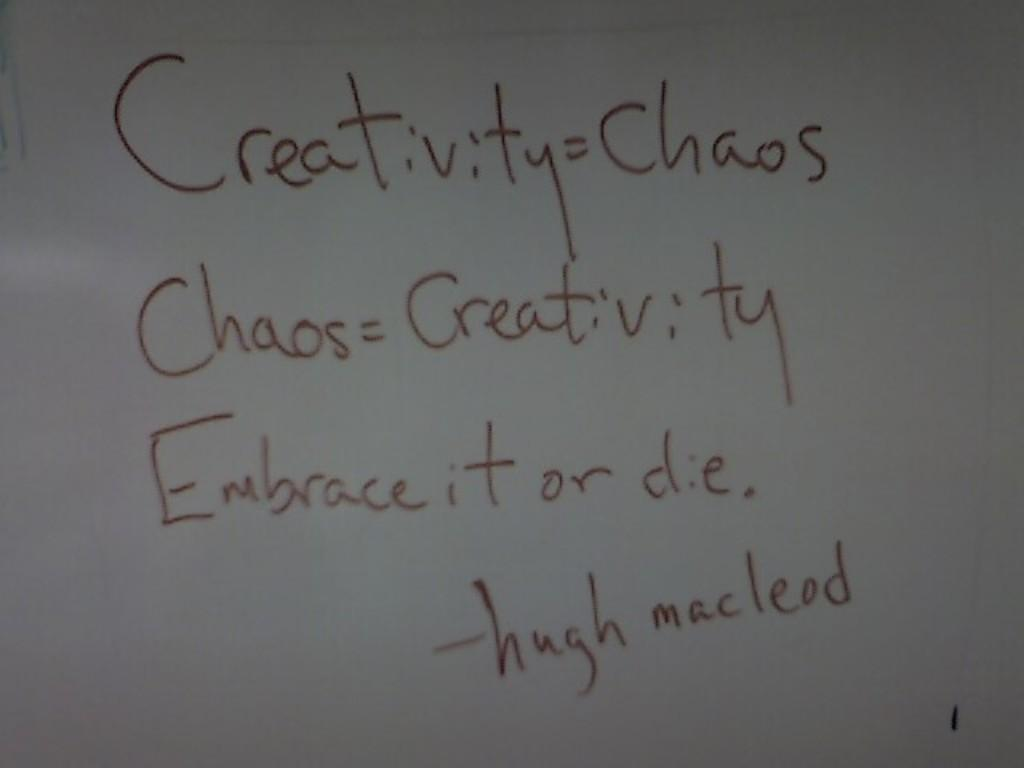Provide a one-sentence caption for the provided image. A whiteboard has black writing on it recalling a Hugh Macleod quotation. 